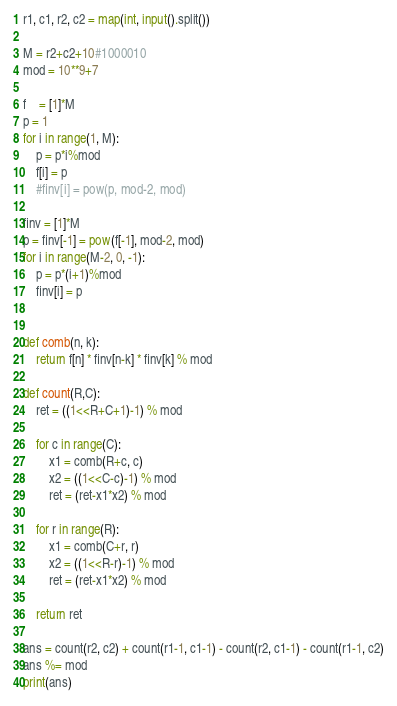<code> <loc_0><loc_0><loc_500><loc_500><_Python_>r1, c1, r2, c2 = map(int, input().split())

M = r2+c2+10#1000010
mod = 10**9+7

f    = [1]*M
p = 1
for i in range(1, M):
    p = p*i%mod
    f[i] = p
    #finv[i] = pow(p, mod-2, mod)

finv = [1]*M
p = finv[-1] = pow(f[-1], mod-2, mod)
for i in range(M-2, 0, -1):
    p = p*(i+1)%mod
    finv[i] = p


def comb(n, k):
    return f[n] * finv[n-k] * finv[k] % mod

def count(R,C):
    ret = ((1<<R+C+1)-1) % mod

    for c in range(C):
        x1 = comb(R+c, c)
        x2 = ((1<<C-c)-1) % mod
        ret = (ret-x1*x2) % mod

    for r in range(R):
        x1 = comb(C+r, r)
        x2 = ((1<<R-r)-1) % mod
        ret = (ret-x1*x2) % mod

    return ret

ans = count(r2, c2) + count(r1-1, c1-1) - count(r2, c1-1) - count(r1-1, c2)
ans %= mod
print(ans)
</code> 